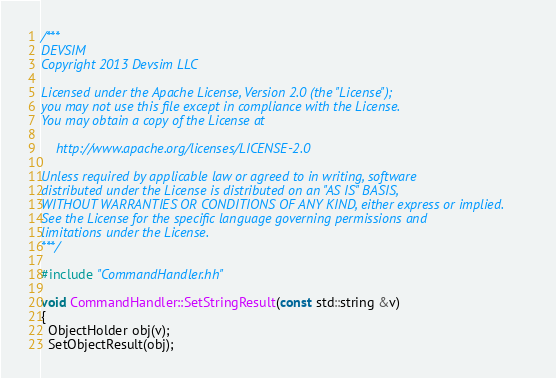<code> <loc_0><loc_0><loc_500><loc_500><_C++_>/***
DEVSIM
Copyright 2013 Devsim LLC

Licensed under the Apache License, Version 2.0 (the "License");
you may not use this file except in compliance with the License.
You may obtain a copy of the License at

    http://www.apache.org/licenses/LICENSE-2.0

Unless required by applicable law or agreed to in writing, software
distributed under the License is distributed on an "AS IS" BASIS,
WITHOUT WARRANTIES OR CONDITIONS OF ANY KIND, either express or implied.
See the License for the specific language governing permissions and
limitations under the License.
***/

#include "CommandHandler.hh"

void CommandHandler::SetStringResult(const std::string &v)
{
  ObjectHolder obj(v);
  SetObjectResult(obj);</code> 